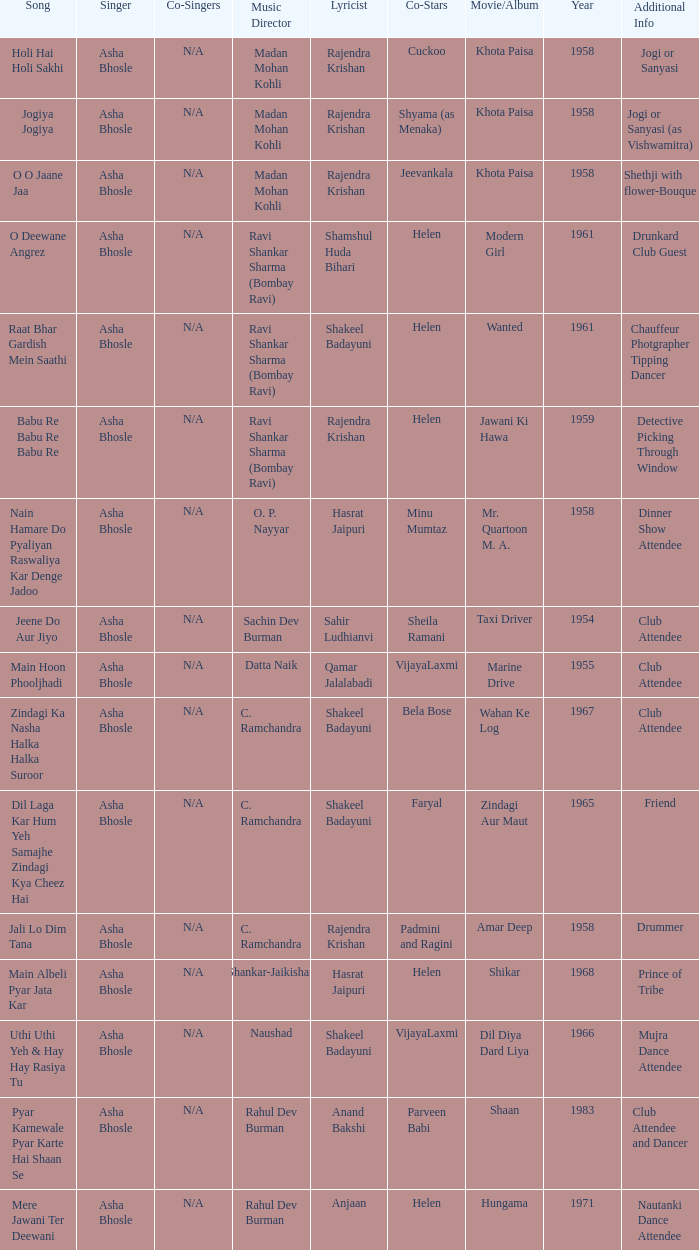Who provided the vocals for the film amar deep? Asha Bhosle. 